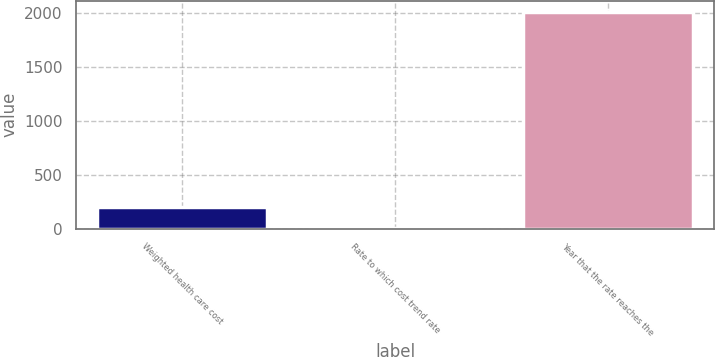Convert chart to OTSL. <chart><loc_0><loc_0><loc_500><loc_500><bar_chart><fcel>Weighted health care cost<fcel>Rate to which cost trend rate<fcel>Year that the rate reaches the<nl><fcel>205.8<fcel>5<fcel>2013<nl></chart> 